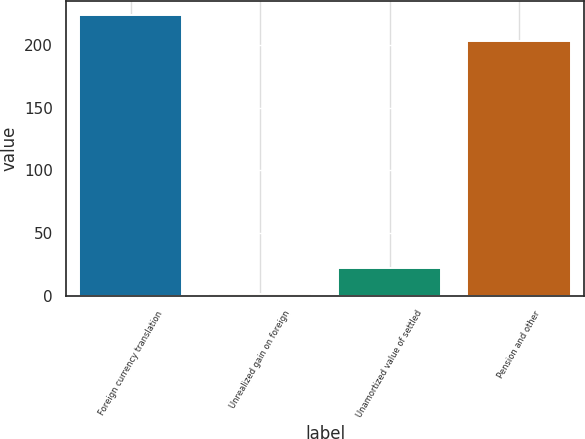Convert chart. <chart><loc_0><loc_0><loc_500><loc_500><bar_chart><fcel>Foreign currency translation<fcel>Unrealized gain on foreign<fcel>Unamortized value of settled<fcel>Pension and other<nl><fcel>223.61<fcel>1.5<fcel>22.01<fcel>203.1<nl></chart> 